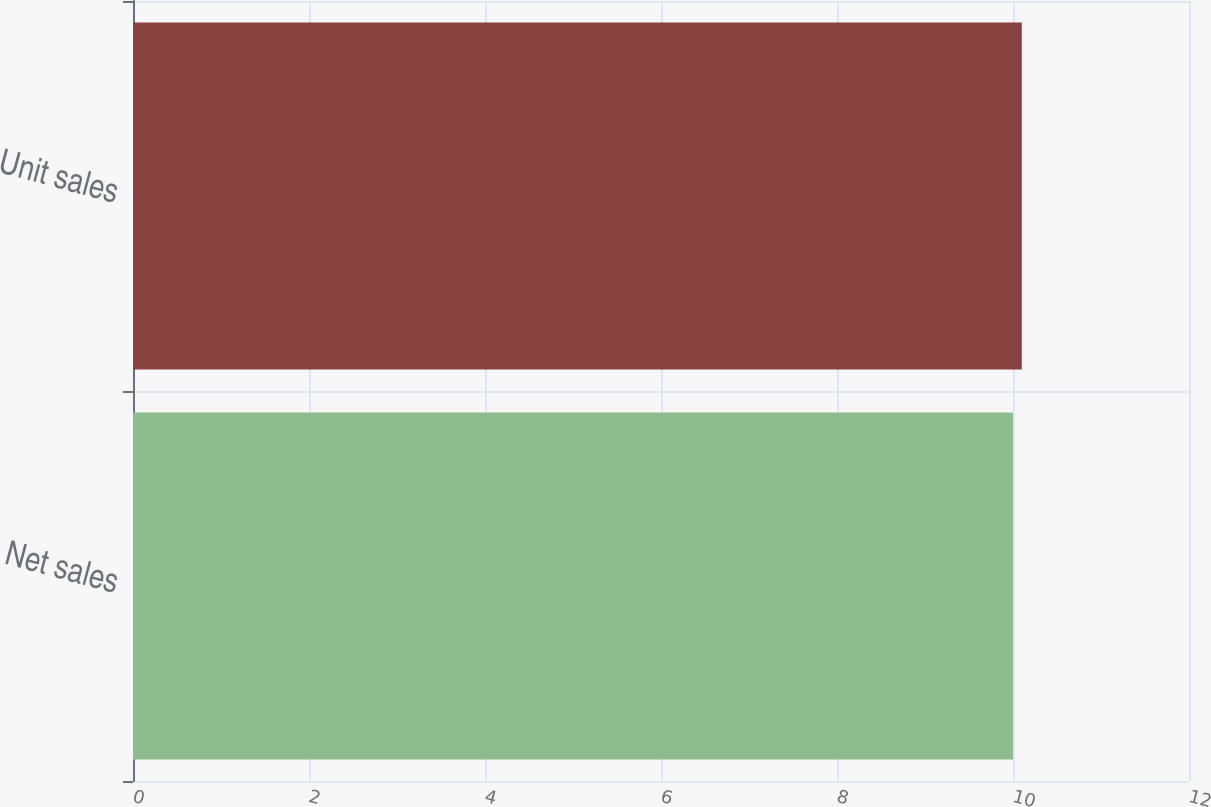<chart> <loc_0><loc_0><loc_500><loc_500><bar_chart><fcel>Net sales<fcel>Unit sales<nl><fcel>10<fcel>10.1<nl></chart> 